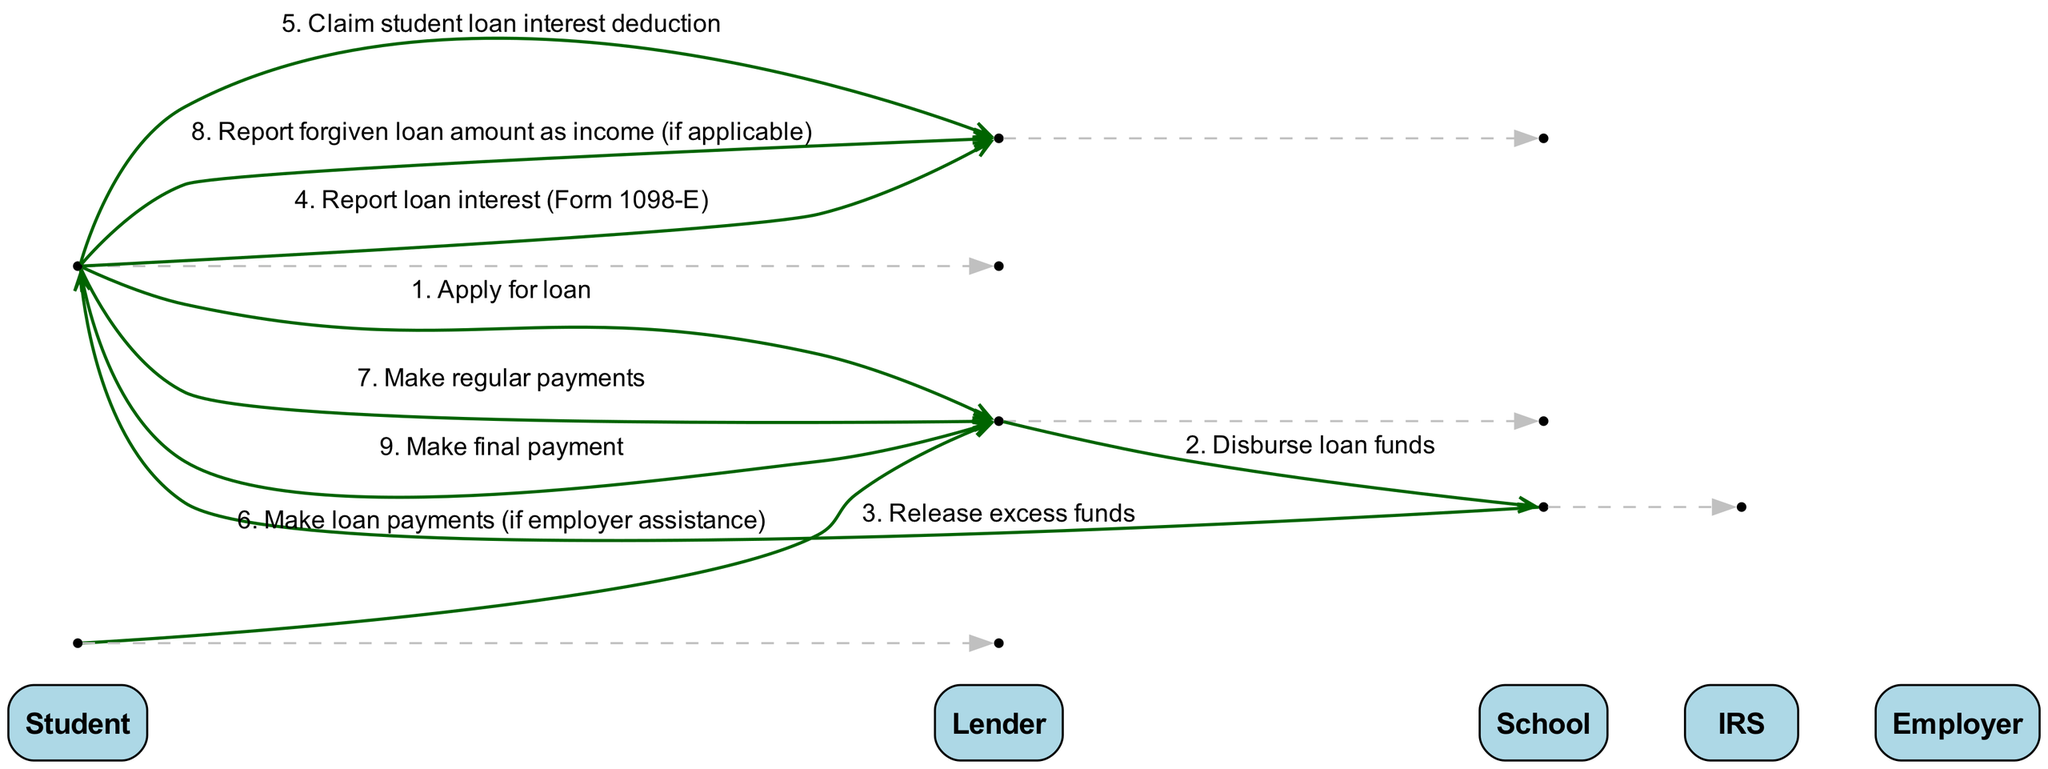What is the first action taken in the student loan lifecycle? The diagram indicates that the first action is the student applying for a loan. This is the first message in the sequence from the Student to the Lender.
Answer: Apply for loan How many actors are involved in the student loan lifecycle? The diagram lists five distinct actors: Student, Lender, School, IRS, and Employer. Counting these gives us a total of five actors in the lifecycle.
Answer: 5 What is the last action taken in this sequence? The last action shown in the sequence is the student making a final payment to the lender. This represents the culmination of the loan lifecycle.
Answer: Make final payment Which entity reports loan interest to the IRS? The diagram shows that it is the Student who reports the loan interest using Form 1098-E, as indicated in the sequence where the Student communicates with the IRS.
Answer: Student What happens after the loan amount is forgiven? According to the diagram, after a loan amount is forgiven, the student is required to report that amount as income to the IRS. This is indicated as a subsequent action in the sequence.
Answer: Report forgiven loan amount as income Which actor is involved in making loan payments if there is employer assistance? The diagram indicates that the Employer is involved in making loan payments if there is employer assistance, as shown in the message directed from Employer to Lender.
Answer: Employer What is the relationship between the Student and Lender during regular payments? The relationship is that the Student makes regular payments to the Lender, as represented in the diagram by the directional message from the Student to the Lender for making regular payments.
Answer: Make regular payments How many messages are exchanged from the Student to the IRS? The diagram shows two distinct messages going from the Student to the IRS: one for reporting loan interest and another for claiming a student loan interest deduction. Counting these gives a total of two messages.
Answer: 2 What is the primary function of the School in this sequence? The School's primary function in this sequence is to release excess funds after the loan funds have been disbursed from the Lender. This action is shown in the direct message from the School to the Student.
Answer: Release excess funds 